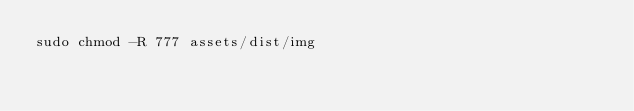<code> <loc_0><loc_0><loc_500><loc_500><_Bash_>sudo chmod -R 777 assets/dist/img</code> 